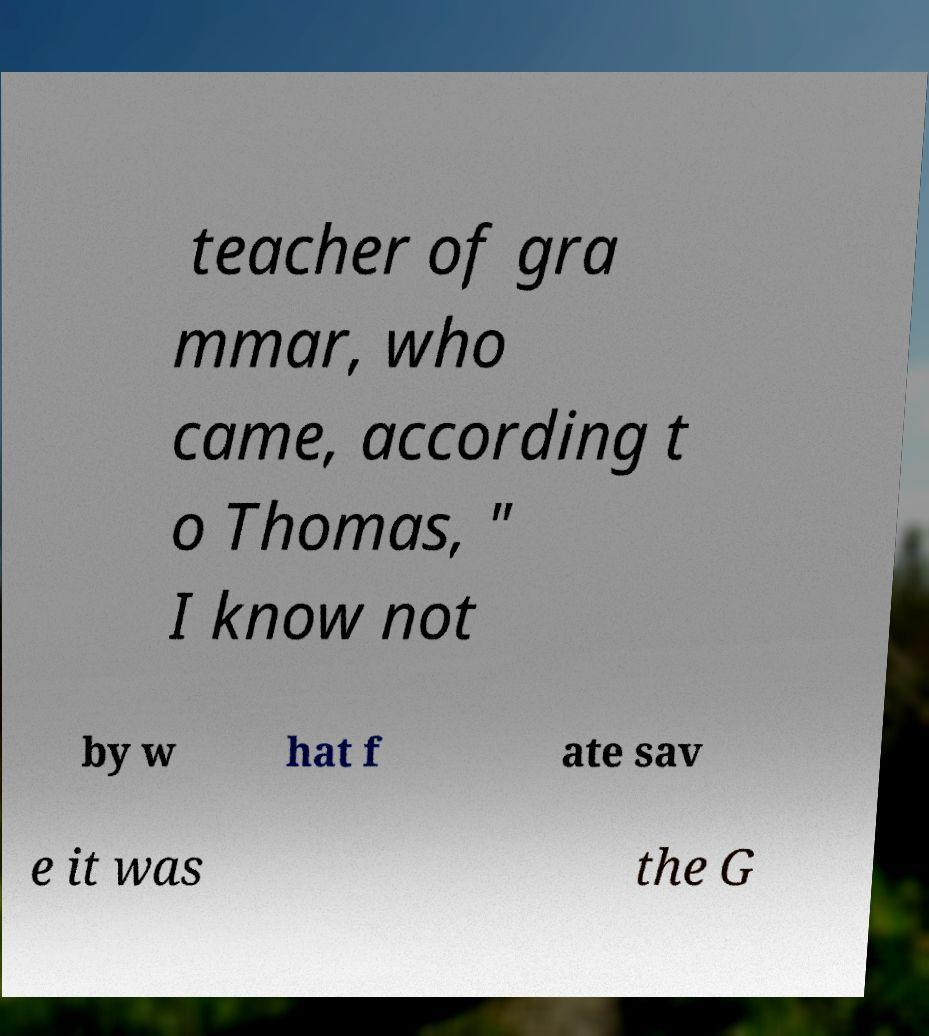There's text embedded in this image that I need extracted. Can you transcribe it verbatim? teacher of gra mmar, who came, according t o Thomas, " I know not by w hat f ate sav e it was the G 